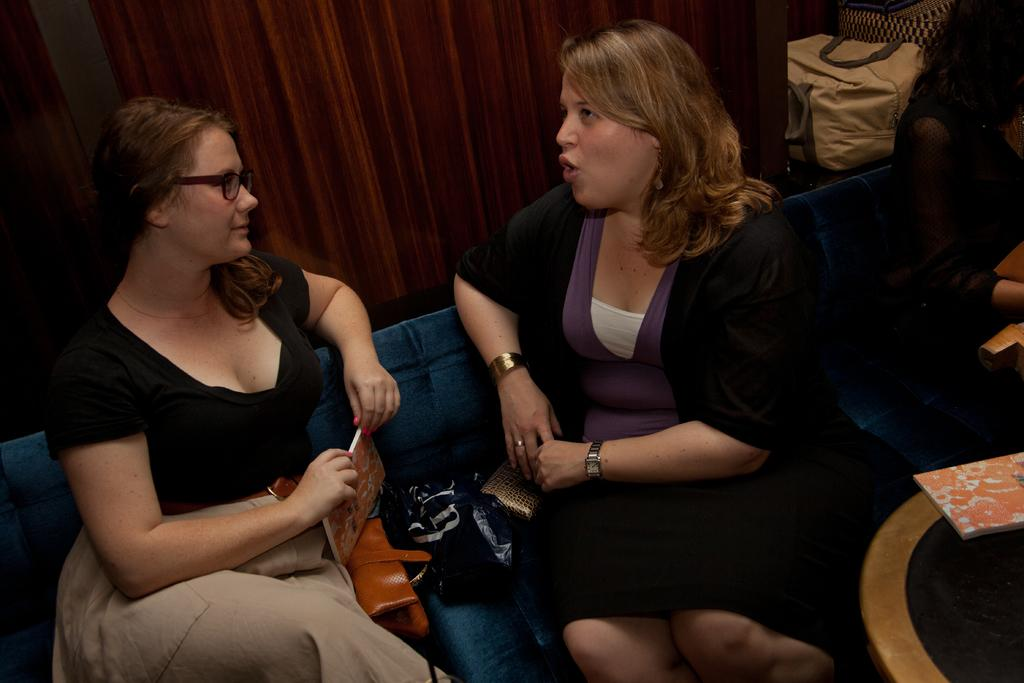How many women are present in the image? There are three women in the image. What are the women doing in the image? The women are sitting on a sofa. Can you describe any objects in the image besides the women? There is a book in the image. What can be seen in the background of the image? There is a wall and bags visible in the background of the image. What type of bell can be heard ringing in the image? There is no bell present or ringing in the image. What authority figure is present in the image? There is no authority figure present in the image. 